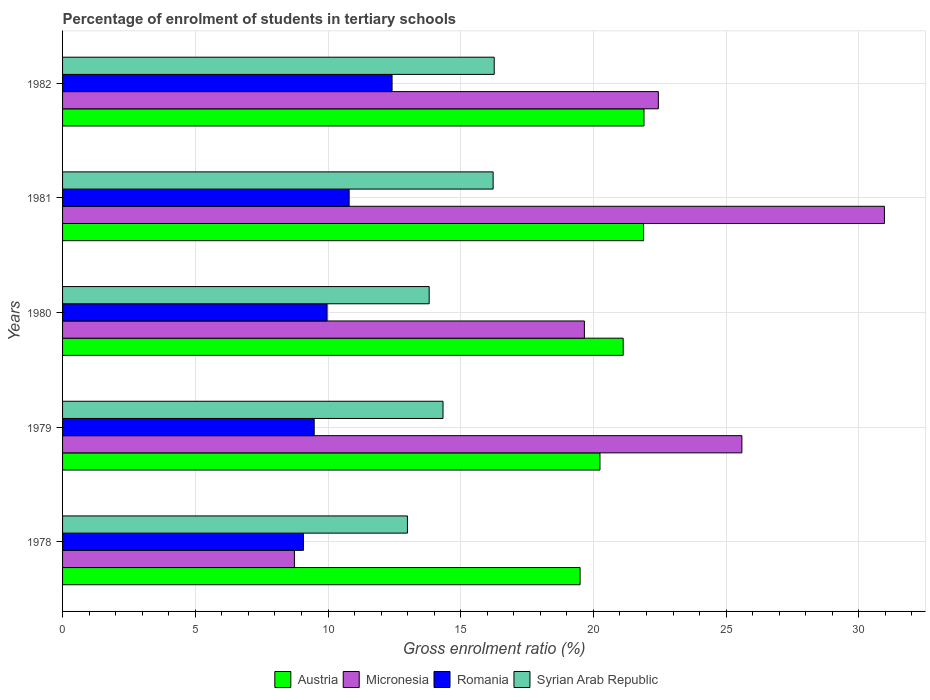How many different coloured bars are there?
Make the answer very short. 4. How many groups of bars are there?
Make the answer very short. 5. Are the number of bars per tick equal to the number of legend labels?
Provide a succinct answer. Yes. Are the number of bars on each tick of the Y-axis equal?
Your response must be concise. Yes. How many bars are there on the 4th tick from the top?
Offer a very short reply. 4. How many bars are there on the 2nd tick from the bottom?
Ensure brevity in your answer.  4. What is the label of the 4th group of bars from the top?
Offer a terse response. 1979. What is the percentage of students enrolled in tertiary schools in Micronesia in 1978?
Ensure brevity in your answer.  8.73. Across all years, what is the maximum percentage of students enrolled in tertiary schools in Syrian Arab Republic?
Provide a succinct answer. 16.26. Across all years, what is the minimum percentage of students enrolled in tertiary schools in Romania?
Ensure brevity in your answer.  9.07. In which year was the percentage of students enrolled in tertiary schools in Austria maximum?
Make the answer very short. 1982. In which year was the percentage of students enrolled in tertiary schools in Romania minimum?
Your response must be concise. 1978. What is the total percentage of students enrolled in tertiary schools in Micronesia in the graph?
Ensure brevity in your answer.  107.4. What is the difference between the percentage of students enrolled in tertiary schools in Romania in 1978 and that in 1980?
Provide a short and direct response. -0.89. What is the difference between the percentage of students enrolled in tertiary schools in Austria in 1980 and the percentage of students enrolled in tertiary schools in Romania in 1979?
Keep it short and to the point. 11.64. What is the average percentage of students enrolled in tertiary schools in Austria per year?
Make the answer very short. 20.93. In the year 1982, what is the difference between the percentage of students enrolled in tertiary schools in Micronesia and percentage of students enrolled in tertiary schools in Romania?
Your answer should be very brief. 10.03. In how many years, is the percentage of students enrolled in tertiary schools in Micronesia greater than 10 %?
Give a very brief answer. 4. What is the ratio of the percentage of students enrolled in tertiary schools in Austria in 1980 to that in 1981?
Your response must be concise. 0.96. Is the difference between the percentage of students enrolled in tertiary schools in Micronesia in 1978 and 1981 greater than the difference between the percentage of students enrolled in tertiary schools in Romania in 1978 and 1981?
Your response must be concise. No. What is the difference between the highest and the second highest percentage of students enrolled in tertiary schools in Austria?
Your answer should be compact. 0.01. What is the difference between the highest and the lowest percentage of students enrolled in tertiary schools in Austria?
Give a very brief answer. 2.41. In how many years, is the percentage of students enrolled in tertiary schools in Austria greater than the average percentage of students enrolled in tertiary schools in Austria taken over all years?
Your answer should be compact. 3. What does the 3rd bar from the top in 1980 represents?
Your answer should be compact. Micronesia. What does the 3rd bar from the bottom in 1982 represents?
Provide a short and direct response. Romania. How many years are there in the graph?
Keep it short and to the point. 5. What is the difference between two consecutive major ticks on the X-axis?
Make the answer very short. 5. Are the values on the major ticks of X-axis written in scientific E-notation?
Keep it short and to the point. No. Does the graph contain grids?
Provide a succinct answer. Yes. How many legend labels are there?
Give a very brief answer. 4. How are the legend labels stacked?
Keep it short and to the point. Horizontal. What is the title of the graph?
Give a very brief answer. Percentage of enrolment of students in tertiary schools. What is the label or title of the X-axis?
Offer a terse response. Gross enrolment ratio (%). What is the label or title of the Y-axis?
Provide a short and direct response. Years. What is the Gross enrolment ratio (%) of Austria in 1978?
Your answer should be compact. 19.5. What is the Gross enrolment ratio (%) in Micronesia in 1978?
Offer a terse response. 8.73. What is the Gross enrolment ratio (%) of Romania in 1978?
Your answer should be compact. 9.07. What is the Gross enrolment ratio (%) in Syrian Arab Republic in 1978?
Offer a very short reply. 12.99. What is the Gross enrolment ratio (%) in Austria in 1979?
Provide a succinct answer. 20.25. What is the Gross enrolment ratio (%) in Micronesia in 1979?
Ensure brevity in your answer.  25.59. What is the Gross enrolment ratio (%) in Romania in 1979?
Ensure brevity in your answer.  9.48. What is the Gross enrolment ratio (%) in Syrian Arab Republic in 1979?
Your answer should be very brief. 14.33. What is the Gross enrolment ratio (%) of Austria in 1980?
Your response must be concise. 21.12. What is the Gross enrolment ratio (%) of Micronesia in 1980?
Make the answer very short. 19.66. What is the Gross enrolment ratio (%) of Romania in 1980?
Offer a very short reply. 9.97. What is the Gross enrolment ratio (%) in Syrian Arab Republic in 1980?
Offer a very short reply. 13.81. What is the Gross enrolment ratio (%) in Austria in 1981?
Keep it short and to the point. 21.89. What is the Gross enrolment ratio (%) in Micronesia in 1981?
Provide a succinct answer. 30.96. What is the Gross enrolment ratio (%) in Romania in 1981?
Keep it short and to the point. 10.8. What is the Gross enrolment ratio (%) of Syrian Arab Republic in 1981?
Your response must be concise. 16.22. What is the Gross enrolment ratio (%) in Austria in 1982?
Your answer should be compact. 21.91. What is the Gross enrolment ratio (%) in Micronesia in 1982?
Offer a very short reply. 22.45. What is the Gross enrolment ratio (%) of Romania in 1982?
Offer a terse response. 12.41. What is the Gross enrolment ratio (%) in Syrian Arab Republic in 1982?
Provide a succinct answer. 16.26. Across all years, what is the maximum Gross enrolment ratio (%) in Austria?
Ensure brevity in your answer.  21.91. Across all years, what is the maximum Gross enrolment ratio (%) of Micronesia?
Provide a succinct answer. 30.96. Across all years, what is the maximum Gross enrolment ratio (%) of Romania?
Your response must be concise. 12.41. Across all years, what is the maximum Gross enrolment ratio (%) of Syrian Arab Republic?
Make the answer very short. 16.26. Across all years, what is the minimum Gross enrolment ratio (%) of Austria?
Give a very brief answer. 19.5. Across all years, what is the minimum Gross enrolment ratio (%) in Micronesia?
Provide a succinct answer. 8.73. Across all years, what is the minimum Gross enrolment ratio (%) in Romania?
Give a very brief answer. 9.07. Across all years, what is the minimum Gross enrolment ratio (%) of Syrian Arab Republic?
Provide a succinct answer. 12.99. What is the total Gross enrolment ratio (%) of Austria in the graph?
Offer a terse response. 104.66. What is the total Gross enrolment ratio (%) of Micronesia in the graph?
Offer a very short reply. 107.4. What is the total Gross enrolment ratio (%) in Romania in the graph?
Offer a very short reply. 51.73. What is the total Gross enrolment ratio (%) of Syrian Arab Republic in the graph?
Offer a very short reply. 73.62. What is the difference between the Gross enrolment ratio (%) of Austria in 1978 and that in 1979?
Make the answer very short. -0.75. What is the difference between the Gross enrolment ratio (%) in Micronesia in 1978 and that in 1979?
Ensure brevity in your answer.  -16.86. What is the difference between the Gross enrolment ratio (%) in Romania in 1978 and that in 1979?
Give a very brief answer. -0.41. What is the difference between the Gross enrolment ratio (%) of Syrian Arab Republic in 1978 and that in 1979?
Offer a very short reply. -1.34. What is the difference between the Gross enrolment ratio (%) in Austria in 1978 and that in 1980?
Provide a short and direct response. -1.62. What is the difference between the Gross enrolment ratio (%) in Micronesia in 1978 and that in 1980?
Your answer should be very brief. -10.93. What is the difference between the Gross enrolment ratio (%) in Romania in 1978 and that in 1980?
Your answer should be very brief. -0.89. What is the difference between the Gross enrolment ratio (%) of Syrian Arab Republic in 1978 and that in 1980?
Offer a terse response. -0.82. What is the difference between the Gross enrolment ratio (%) of Austria in 1978 and that in 1981?
Make the answer very short. -2.39. What is the difference between the Gross enrolment ratio (%) in Micronesia in 1978 and that in 1981?
Offer a terse response. -22.23. What is the difference between the Gross enrolment ratio (%) in Romania in 1978 and that in 1981?
Your answer should be compact. -1.72. What is the difference between the Gross enrolment ratio (%) of Syrian Arab Republic in 1978 and that in 1981?
Make the answer very short. -3.23. What is the difference between the Gross enrolment ratio (%) in Austria in 1978 and that in 1982?
Your answer should be very brief. -2.41. What is the difference between the Gross enrolment ratio (%) of Micronesia in 1978 and that in 1982?
Your answer should be compact. -13.71. What is the difference between the Gross enrolment ratio (%) in Romania in 1978 and that in 1982?
Offer a very short reply. -3.34. What is the difference between the Gross enrolment ratio (%) in Syrian Arab Republic in 1978 and that in 1982?
Your answer should be compact. -3.27. What is the difference between the Gross enrolment ratio (%) of Austria in 1979 and that in 1980?
Your answer should be compact. -0.87. What is the difference between the Gross enrolment ratio (%) of Micronesia in 1979 and that in 1980?
Offer a very short reply. 5.93. What is the difference between the Gross enrolment ratio (%) of Romania in 1979 and that in 1980?
Provide a short and direct response. -0.49. What is the difference between the Gross enrolment ratio (%) in Syrian Arab Republic in 1979 and that in 1980?
Give a very brief answer. 0.52. What is the difference between the Gross enrolment ratio (%) in Austria in 1979 and that in 1981?
Offer a very short reply. -1.64. What is the difference between the Gross enrolment ratio (%) in Micronesia in 1979 and that in 1981?
Provide a succinct answer. -5.37. What is the difference between the Gross enrolment ratio (%) of Romania in 1979 and that in 1981?
Your answer should be compact. -1.32. What is the difference between the Gross enrolment ratio (%) of Syrian Arab Republic in 1979 and that in 1981?
Your answer should be very brief. -1.89. What is the difference between the Gross enrolment ratio (%) in Austria in 1979 and that in 1982?
Make the answer very short. -1.66. What is the difference between the Gross enrolment ratio (%) of Micronesia in 1979 and that in 1982?
Offer a terse response. 3.15. What is the difference between the Gross enrolment ratio (%) of Romania in 1979 and that in 1982?
Your response must be concise. -2.93. What is the difference between the Gross enrolment ratio (%) in Syrian Arab Republic in 1979 and that in 1982?
Make the answer very short. -1.93. What is the difference between the Gross enrolment ratio (%) of Austria in 1980 and that in 1981?
Your answer should be compact. -0.77. What is the difference between the Gross enrolment ratio (%) in Micronesia in 1980 and that in 1981?
Provide a succinct answer. -11.3. What is the difference between the Gross enrolment ratio (%) of Romania in 1980 and that in 1981?
Your response must be concise. -0.83. What is the difference between the Gross enrolment ratio (%) of Syrian Arab Republic in 1980 and that in 1981?
Offer a terse response. -2.41. What is the difference between the Gross enrolment ratio (%) of Austria in 1980 and that in 1982?
Ensure brevity in your answer.  -0.78. What is the difference between the Gross enrolment ratio (%) in Micronesia in 1980 and that in 1982?
Ensure brevity in your answer.  -2.79. What is the difference between the Gross enrolment ratio (%) in Romania in 1980 and that in 1982?
Provide a succinct answer. -2.45. What is the difference between the Gross enrolment ratio (%) of Syrian Arab Republic in 1980 and that in 1982?
Provide a succinct answer. -2.45. What is the difference between the Gross enrolment ratio (%) of Austria in 1981 and that in 1982?
Give a very brief answer. -0.01. What is the difference between the Gross enrolment ratio (%) of Micronesia in 1981 and that in 1982?
Ensure brevity in your answer.  8.52. What is the difference between the Gross enrolment ratio (%) in Romania in 1981 and that in 1982?
Ensure brevity in your answer.  -1.62. What is the difference between the Gross enrolment ratio (%) of Syrian Arab Republic in 1981 and that in 1982?
Your response must be concise. -0.04. What is the difference between the Gross enrolment ratio (%) in Austria in 1978 and the Gross enrolment ratio (%) in Micronesia in 1979?
Keep it short and to the point. -6.1. What is the difference between the Gross enrolment ratio (%) in Austria in 1978 and the Gross enrolment ratio (%) in Romania in 1979?
Your response must be concise. 10.02. What is the difference between the Gross enrolment ratio (%) in Austria in 1978 and the Gross enrolment ratio (%) in Syrian Arab Republic in 1979?
Offer a terse response. 5.16. What is the difference between the Gross enrolment ratio (%) of Micronesia in 1978 and the Gross enrolment ratio (%) of Romania in 1979?
Keep it short and to the point. -0.74. What is the difference between the Gross enrolment ratio (%) in Micronesia in 1978 and the Gross enrolment ratio (%) in Syrian Arab Republic in 1979?
Ensure brevity in your answer.  -5.6. What is the difference between the Gross enrolment ratio (%) in Romania in 1978 and the Gross enrolment ratio (%) in Syrian Arab Republic in 1979?
Give a very brief answer. -5.26. What is the difference between the Gross enrolment ratio (%) in Austria in 1978 and the Gross enrolment ratio (%) in Micronesia in 1980?
Offer a terse response. -0.16. What is the difference between the Gross enrolment ratio (%) in Austria in 1978 and the Gross enrolment ratio (%) in Romania in 1980?
Your answer should be compact. 9.53. What is the difference between the Gross enrolment ratio (%) of Austria in 1978 and the Gross enrolment ratio (%) of Syrian Arab Republic in 1980?
Keep it short and to the point. 5.69. What is the difference between the Gross enrolment ratio (%) in Micronesia in 1978 and the Gross enrolment ratio (%) in Romania in 1980?
Your answer should be compact. -1.23. What is the difference between the Gross enrolment ratio (%) in Micronesia in 1978 and the Gross enrolment ratio (%) in Syrian Arab Republic in 1980?
Offer a terse response. -5.08. What is the difference between the Gross enrolment ratio (%) in Romania in 1978 and the Gross enrolment ratio (%) in Syrian Arab Republic in 1980?
Provide a succinct answer. -4.74. What is the difference between the Gross enrolment ratio (%) of Austria in 1978 and the Gross enrolment ratio (%) of Micronesia in 1981?
Provide a succinct answer. -11.47. What is the difference between the Gross enrolment ratio (%) of Austria in 1978 and the Gross enrolment ratio (%) of Romania in 1981?
Give a very brief answer. 8.7. What is the difference between the Gross enrolment ratio (%) of Austria in 1978 and the Gross enrolment ratio (%) of Syrian Arab Republic in 1981?
Make the answer very short. 3.28. What is the difference between the Gross enrolment ratio (%) of Micronesia in 1978 and the Gross enrolment ratio (%) of Romania in 1981?
Keep it short and to the point. -2.06. What is the difference between the Gross enrolment ratio (%) in Micronesia in 1978 and the Gross enrolment ratio (%) in Syrian Arab Republic in 1981?
Give a very brief answer. -7.49. What is the difference between the Gross enrolment ratio (%) of Romania in 1978 and the Gross enrolment ratio (%) of Syrian Arab Republic in 1981?
Provide a short and direct response. -7.15. What is the difference between the Gross enrolment ratio (%) of Austria in 1978 and the Gross enrolment ratio (%) of Micronesia in 1982?
Your response must be concise. -2.95. What is the difference between the Gross enrolment ratio (%) in Austria in 1978 and the Gross enrolment ratio (%) in Romania in 1982?
Give a very brief answer. 7.08. What is the difference between the Gross enrolment ratio (%) in Austria in 1978 and the Gross enrolment ratio (%) in Syrian Arab Republic in 1982?
Provide a succinct answer. 3.24. What is the difference between the Gross enrolment ratio (%) in Micronesia in 1978 and the Gross enrolment ratio (%) in Romania in 1982?
Offer a very short reply. -3.68. What is the difference between the Gross enrolment ratio (%) in Micronesia in 1978 and the Gross enrolment ratio (%) in Syrian Arab Republic in 1982?
Keep it short and to the point. -7.53. What is the difference between the Gross enrolment ratio (%) in Romania in 1978 and the Gross enrolment ratio (%) in Syrian Arab Republic in 1982?
Ensure brevity in your answer.  -7.19. What is the difference between the Gross enrolment ratio (%) of Austria in 1979 and the Gross enrolment ratio (%) of Micronesia in 1980?
Provide a succinct answer. 0.59. What is the difference between the Gross enrolment ratio (%) in Austria in 1979 and the Gross enrolment ratio (%) in Romania in 1980?
Give a very brief answer. 10.28. What is the difference between the Gross enrolment ratio (%) of Austria in 1979 and the Gross enrolment ratio (%) of Syrian Arab Republic in 1980?
Keep it short and to the point. 6.43. What is the difference between the Gross enrolment ratio (%) of Micronesia in 1979 and the Gross enrolment ratio (%) of Romania in 1980?
Ensure brevity in your answer.  15.63. What is the difference between the Gross enrolment ratio (%) of Micronesia in 1979 and the Gross enrolment ratio (%) of Syrian Arab Republic in 1980?
Your answer should be compact. 11.78. What is the difference between the Gross enrolment ratio (%) of Romania in 1979 and the Gross enrolment ratio (%) of Syrian Arab Republic in 1980?
Provide a succinct answer. -4.33. What is the difference between the Gross enrolment ratio (%) in Austria in 1979 and the Gross enrolment ratio (%) in Micronesia in 1981?
Offer a terse response. -10.72. What is the difference between the Gross enrolment ratio (%) of Austria in 1979 and the Gross enrolment ratio (%) of Romania in 1981?
Ensure brevity in your answer.  9.45. What is the difference between the Gross enrolment ratio (%) of Austria in 1979 and the Gross enrolment ratio (%) of Syrian Arab Republic in 1981?
Ensure brevity in your answer.  4.02. What is the difference between the Gross enrolment ratio (%) in Micronesia in 1979 and the Gross enrolment ratio (%) in Romania in 1981?
Ensure brevity in your answer.  14.8. What is the difference between the Gross enrolment ratio (%) in Micronesia in 1979 and the Gross enrolment ratio (%) in Syrian Arab Republic in 1981?
Your answer should be compact. 9.37. What is the difference between the Gross enrolment ratio (%) of Romania in 1979 and the Gross enrolment ratio (%) of Syrian Arab Republic in 1981?
Offer a very short reply. -6.74. What is the difference between the Gross enrolment ratio (%) in Austria in 1979 and the Gross enrolment ratio (%) in Micronesia in 1982?
Give a very brief answer. -2.2. What is the difference between the Gross enrolment ratio (%) of Austria in 1979 and the Gross enrolment ratio (%) of Romania in 1982?
Make the answer very short. 7.83. What is the difference between the Gross enrolment ratio (%) of Austria in 1979 and the Gross enrolment ratio (%) of Syrian Arab Republic in 1982?
Your response must be concise. 3.98. What is the difference between the Gross enrolment ratio (%) of Micronesia in 1979 and the Gross enrolment ratio (%) of Romania in 1982?
Provide a short and direct response. 13.18. What is the difference between the Gross enrolment ratio (%) in Micronesia in 1979 and the Gross enrolment ratio (%) in Syrian Arab Republic in 1982?
Make the answer very short. 9.33. What is the difference between the Gross enrolment ratio (%) of Romania in 1979 and the Gross enrolment ratio (%) of Syrian Arab Republic in 1982?
Provide a short and direct response. -6.78. What is the difference between the Gross enrolment ratio (%) in Austria in 1980 and the Gross enrolment ratio (%) in Micronesia in 1981?
Give a very brief answer. -9.84. What is the difference between the Gross enrolment ratio (%) of Austria in 1980 and the Gross enrolment ratio (%) of Romania in 1981?
Give a very brief answer. 10.33. What is the difference between the Gross enrolment ratio (%) of Austria in 1980 and the Gross enrolment ratio (%) of Syrian Arab Republic in 1981?
Make the answer very short. 4.9. What is the difference between the Gross enrolment ratio (%) in Micronesia in 1980 and the Gross enrolment ratio (%) in Romania in 1981?
Offer a terse response. 8.86. What is the difference between the Gross enrolment ratio (%) in Micronesia in 1980 and the Gross enrolment ratio (%) in Syrian Arab Republic in 1981?
Offer a terse response. 3.44. What is the difference between the Gross enrolment ratio (%) of Romania in 1980 and the Gross enrolment ratio (%) of Syrian Arab Republic in 1981?
Offer a very short reply. -6.26. What is the difference between the Gross enrolment ratio (%) in Austria in 1980 and the Gross enrolment ratio (%) in Micronesia in 1982?
Ensure brevity in your answer.  -1.32. What is the difference between the Gross enrolment ratio (%) in Austria in 1980 and the Gross enrolment ratio (%) in Romania in 1982?
Provide a succinct answer. 8.71. What is the difference between the Gross enrolment ratio (%) of Austria in 1980 and the Gross enrolment ratio (%) of Syrian Arab Republic in 1982?
Your answer should be compact. 4.86. What is the difference between the Gross enrolment ratio (%) of Micronesia in 1980 and the Gross enrolment ratio (%) of Romania in 1982?
Give a very brief answer. 7.25. What is the difference between the Gross enrolment ratio (%) of Micronesia in 1980 and the Gross enrolment ratio (%) of Syrian Arab Republic in 1982?
Ensure brevity in your answer.  3.4. What is the difference between the Gross enrolment ratio (%) of Romania in 1980 and the Gross enrolment ratio (%) of Syrian Arab Republic in 1982?
Ensure brevity in your answer.  -6.3. What is the difference between the Gross enrolment ratio (%) of Austria in 1981 and the Gross enrolment ratio (%) of Micronesia in 1982?
Make the answer very short. -0.56. What is the difference between the Gross enrolment ratio (%) of Austria in 1981 and the Gross enrolment ratio (%) of Romania in 1982?
Offer a terse response. 9.48. What is the difference between the Gross enrolment ratio (%) of Austria in 1981 and the Gross enrolment ratio (%) of Syrian Arab Republic in 1982?
Provide a short and direct response. 5.63. What is the difference between the Gross enrolment ratio (%) in Micronesia in 1981 and the Gross enrolment ratio (%) in Romania in 1982?
Offer a terse response. 18.55. What is the difference between the Gross enrolment ratio (%) in Micronesia in 1981 and the Gross enrolment ratio (%) in Syrian Arab Republic in 1982?
Offer a terse response. 14.7. What is the difference between the Gross enrolment ratio (%) of Romania in 1981 and the Gross enrolment ratio (%) of Syrian Arab Republic in 1982?
Your response must be concise. -5.47. What is the average Gross enrolment ratio (%) in Austria per year?
Offer a very short reply. 20.93. What is the average Gross enrolment ratio (%) in Micronesia per year?
Offer a terse response. 21.48. What is the average Gross enrolment ratio (%) in Romania per year?
Offer a very short reply. 10.35. What is the average Gross enrolment ratio (%) of Syrian Arab Republic per year?
Your response must be concise. 14.72. In the year 1978, what is the difference between the Gross enrolment ratio (%) of Austria and Gross enrolment ratio (%) of Micronesia?
Provide a short and direct response. 10.76. In the year 1978, what is the difference between the Gross enrolment ratio (%) of Austria and Gross enrolment ratio (%) of Romania?
Keep it short and to the point. 10.42. In the year 1978, what is the difference between the Gross enrolment ratio (%) of Austria and Gross enrolment ratio (%) of Syrian Arab Republic?
Provide a short and direct response. 6.5. In the year 1978, what is the difference between the Gross enrolment ratio (%) in Micronesia and Gross enrolment ratio (%) in Romania?
Offer a terse response. -0.34. In the year 1978, what is the difference between the Gross enrolment ratio (%) of Micronesia and Gross enrolment ratio (%) of Syrian Arab Republic?
Ensure brevity in your answer.  -4.26. In the year 1978, what is the difference between the Gross enrolment ratio (%) in Romania and Gross enrolment ratio (%) in Syrian Arab Republic?
Provide a succinct answer. -3.92. In the year 1979, what is the difference between the Gross enrolment ratio (%) of Austria and Gross enrolment ratio (%) of Micronesia?
Offer a terse response. -5.35. In the year 1979, what is the difference between the Gross enrolment ratio (%) in Austria and Gross enrolment ratio (%) in Romania?
Make the answer very short. 10.77. In the year 1979, what is the difference between the Gross enrolment ratio (%) in Austria and Gross enrolment ratio (%) in Syrian Arab Republic?
Keep it short and to the point. 5.91. In the year 1979, what is the difference between the Gross enrolment ratio (%) in Micronesia and Gross enrolment ratio (%) in Romania?
Keep it short and to the point. 16.11. In the year 1979, what is the difference between the Gross enrolment ratio (%) of Micronesia and Gross enrolment ratio (%) of Syrian Arab Republic?
Ensure brevity in your answer.  11.26. In the year 1979, what is the difference between the Gross enrolment ratio (%) of Romania and Gross enrolment ratio (%) of Syrian Arab Republic?
Your response must be concise. -4.85. In the year 1980, what is the difference between the Gross enrolment ratio (%) of Austria and Gross enrolment ratio (%) of Micronesia?
Your answer should be compact. 1.46. In the year 1980, what is the difference between the Gross enrolment ratio (%) of Austria and Gross enrolment ratio (%) of Romania?
Your response must be concise. 11.16. In the year 1980, what is the difference between the Gross enrolment ratio (%) of Austria and Gross enrolment ratio (%) of Syrian Arab Republic?
Offer a terse response. 7.31. In the year 1980, what is the difference between the Gross enrolment ratio (%) of Micronesia and Gross enrolment ratio (%) of Romania?
Your answer should be very brief. 9.69. In the year 1980, what is the difference between the Gross enrolment ratio (%) in Micronesia and Gross enrolment ratio (%) in Syrian Arab Republic?
Offer a very short reply. 5.85. In the year 1980, what is the difference between the Gross enrolment ratio (%) in Romania and Gross enrolment ratio (%) in Syrian Arab Republic?
Provide a short and direct response. -3.85. In the year 1981, what is the difference between the Gross enrolment ratio (%) in Austria and Gross enrolment ratio (%) in Micronesia?
Offer a terse response. -9.07. In the year 1981, what is the difference between the Gross enrolment ratio (%) of Austria and Gross enrolment ratio (%) of Romania?
Your answer should be very brief. 11.09. In the year 1981, what is the difference between the Gross enrolment ratio (%) of Austria and Gross enrolment ratio (%) of Syrian Arab Republic?
Your answer should be compact. 5.67. In the year 1981, what is the difference between the Gross enrolment ratio (%) of Micronesia and Gross enrolment ratio (%) of Romania?
Keep it short and to the point. 20.17. In the year 1981, what is the difference between the Gross enrolment ratio (%) of Micronesia and Gross enrolment ratio (%) of Syrian Arab Republic?
Your answer should be very brief. 14.74. In the year 1981, what is the difference between the Gross enrolment ratio (%) in Romania and Gross enrolment ratio (%) in Syrian Arab Republic?
Keep it short and to the point. -5.43. In the year 1982, what is the difference between the Gross enrolment ratio (%) of Austria and Gross enrolment ratio (%) of Micronesia?
Give a very brief answer. -0.54. In the year 1982, what is the difference between the Gross enrolment ratio (%) in Austria and Gross enrolment ratio (%) in Romania?
Ensure brevity in your answer.  9.49. In the year 1982, what is the difference between the Gross enrolment ratio (%) in Austria and Gross enrolment ratio (%) in Syrian Arab Republic?
Make the answer very short. 5.64. In the year 1982, what is the difference between the Gross enrolment ratio (%) in Micronesia and Gross enrolment ratio (%) in Romania?
Offer a very short reply. 10.03. In the year 1982, what is the difference between the Gross enrolment ratio (%) of Micronesia and Gross enrolment ratio (%) of Syrian Arab Republic?
Provide a short and direct response. 6.18. In the year 1982, what is the difference between the Gross enrolment ratio (%) in Romania and Gross enrolment ratio (%) in Syrian Arab Republic?
Provide a short and direct response. -3.85. What is the ratio of the Gross enrolment ratio (%) of Austria in 1978 to that in 1979?
Keep it short and to the point. 0.96. What is the ratio of the Gross enrolment ratio (%) in Micronesia in 1978 to that in 1979?
Provide a short and direct response. 0.34. What is the ratio of the Gross enrolment ratio (%) of Romania in 1978 to that in 1979?
Provide a short and direct response. 0.96. What is the ratio of the Gross enrolment ratio (%) of Syrian Arab Republic in 1978 to that in 1979?
Provide a succinct answer. 0.91. What is the ratio of the Gross enrolment ratio (%) in Micronesia in 1978 to that in 1980?
Provide a succinct answer. 0.44. What is the ratio of the Gross enrolment ratio (%) of Romania in 1978 to that in 1980?
Ensure brevity in your answer.  0.91. What is the ratio of the Gross enrolment ratio (%) in Syrian Arab Republic in 1978 to that in 1980?
Keep it short and to the point. 0.94. What is the ratio of the Gross enrolment ratio (%) of Austria in 1978 to that in 1981?
Make the answer very short. 0.89. What is the ratio of the Gross enrolment ratio (%) in Micronesia in 1978 to that in 1981?
Your response must be concise. 0.28. What is the ratio of the Gross enrolment ratio (%) of Romania in 1978 to that in 1981?
Your answer should be very brief. 0.84. What is the ratio of the Gross enrolment ratio (%) of Syrian Arab Republic in 1978 to that in 1981?
Provide a succinct answer. 0.8. What is the ratio of the Gross enrolment ratio (%) of Austria in 1978 to that in 1982?
Provide a succinct answer. 0.89. What is the ratio of the Gross enrolment ratio (%) in Micronesia in 1978 to that in 1982?
Offer a terse response. 0.39. What is the ratio of the Gross enrolment ratio (%) of Romania in 1978 to that in 1982?
Make the answer very short. 0.73. What is the ratio of the Gross enrolment ratio (%) of Syrian Arab Republic in 1978 to that in 1982?
Make the answer very short. 0.8. What is the ratio of the Gross enrolment ratio (%) in Austria in 1979 to that in 1980?
Offer a terse response. 0.96. What is the ratio of the Gross enrolment ratio (%) of Micronesia in 1979 to that in 1980?
Your response must be concise. 1.3. What is the ratio of the Gross enrolment ratio (%) of Romania in 1979 to that in 1980?
Offer a terse response. 0.95. What is the ratio of the Gross enrolment ratio (%) of Syrian Arab Republic in 1979 to that in 1980?
Make the answer very short. 1.04. What is the ratio of the Gross enrolment ratio (%) of Austria in 1979 to that in 1981?
Offer a very short reply. 0.92. What is the ratio of the Gross enrolment ratio (%) in Micronesia in 1979 to that in 1981?
Provide a succinct answer. 0.83. What is the ratio of the Gross enrolment ratio (%) of Romania in 1979 to that in 1981?
Provide a short and direct response. 0.88. What is the ratio of the Gross enrolment ratio (%) in Syrian Arab Republic in 1979 to that in 1981?
Give a very brief answer. 0.88. What is the ratio of the Gross enrolment ratio (%) in Austria in 1979 to that in 1982?
Your answer should be very brief. 0.92. What is the ratio of the Gross enrolment ratio (%) in Micronesia in 1979 to that in 1982?
Provide a succinct answer. 1.14. What is the ratio of the Gross enrolment ratio (%) in Romania in 1979 to that in 1982?
Keep it short and to the point. 0.76. What is the ratio of the Gross enrolment ratio (%) in Syrian Arab Republic in 1979 to that in 1982?
Give a very brief answer. 0.88. What is the ratio of the Gross enrolment ratio (%) in Austria in 1980 to that in 1981?
Make the answer very short. 0.96. What is the ratio of the Gross enrolment ratio (%) of Micronesia in 1980 to that in 1981?
Offer a terse response. 0.63. What is the ratio of the Gross enrolment ratio (%) of Romania in 1980 to that in 1981?
Provide a short and direct response. 0.92. What is the ratio of the Gross enrolment ratio (%) of Syrian Arab Republic in 1980 to that in 1981?
Your answer should be compact. 0.85. What is the ratio of the Gross enrolment ratio (%) of Austria in 1980 to that in 1982?
Provide a short and direct response. 0.96. What is the ratio of the Gross enrolment ratio (%) in Micronesia in 1980 to that in 1982?
Ensure brevity in your answer.  0.88. What is the ratio of the Gross enrolment ratio (%) in Romania in 1980 to that in 1982?
Your answer should be very brief. 0.8. What is the ratio of the Gross enrolment ratio (%) in Syrian Arab Republic in 1980 to that in 1982?
Offer a very short reply. 0.85. What is the ratio of the Gross enrolment ratio (%) in Micronesia in 1981 to that in 1982?
Ensure brevity in your answer.  1.38. What is the ratio of the Gross enrolment ratio (%) of Romania in 1981 to that in 1982?
Keep it short and to the point. 0.87. What is the ratio of the Gross enrolment ratio (%) in Syrian Arab Republic in 1981 to that in 1982?
Give a very brief answer. 1. What is the difference between the highest and the second highest Gross enrolment ratio (%) in Austria?
Your answer should be compact. 0.01. What is the difference between the highest and the second highest Gross enrolment ratio (%) of Micronesia?
Keep it short and to the point. 5.37. What is the difference between the highest and the second highest Gross enrolment ratio (%) of Romania?
Your answer should be compact. 1.62. What is the difference between the highest and the second highest Gross enrolment ratio (%) in Syrian Arab Republic?
Your answer should be very brief. 0.04. What is the difference between the highest and the lowest Gross enrolment ratio (%) in Austria?
Offer a very short reply. 2.41. What is the difference between the highest and the lowest Gross enrolment ratio (%) in Micronesia?
Make the answer very short. 22.23. What is the difference between the highest and the lowest Gross enrolment ratio (%) of Romania?
Your answer should be very brief. 3.34. What is the difference between the highest and the lowest Gross enrolment ratio (%) of Syrian Arab Republic?
Make the answer very short. 3.27. 